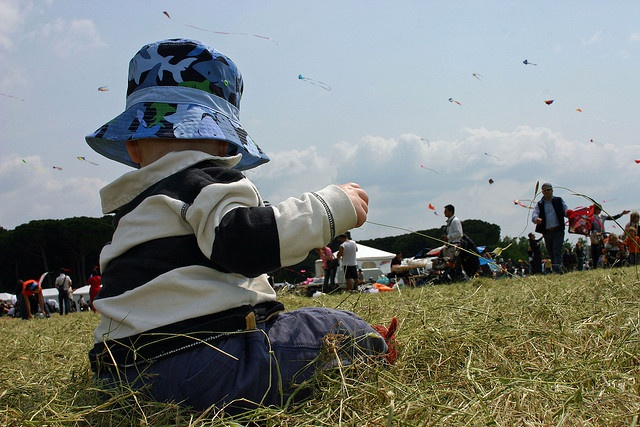Describe the objects in this image and their specific colors. I can see people in lightgray, black, gray, darkgray, and olive tones, kite in lightgray, darkgray, and black tones, people in lightgray, black, blue, navy, and gray tones, people in lightgray, black, gray, darkgray, and white tones, and people in lightgray, black, gray, and darkgray tones in this image. 